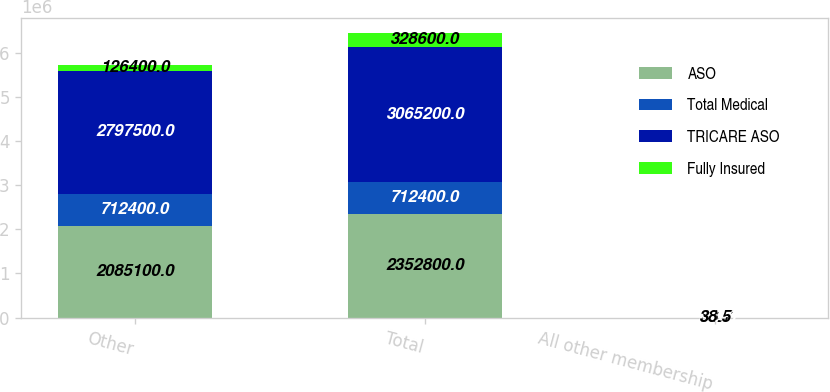<chart> <loc_0><loc_0><loc_500><loc_500><stacked_bar_chart><ecel><fcel>Other<fcel>Total<fcel>All other membership<nl><fcel>ASO<fcel>2.0851e+06<fcel>2.3528e+06<fcel>88.7<nl><fcel>Total Medical<fcel>712400<fcel>712400<fcel>100<nl><fcel>TRICARE ASO<fcel>2.7975e+06<fcel>3.0652e+06<fcel>91.3<nl><fcel>Fully Insured<fcel>126400<fcel>328600<fcel>38.5<nl></chart> 